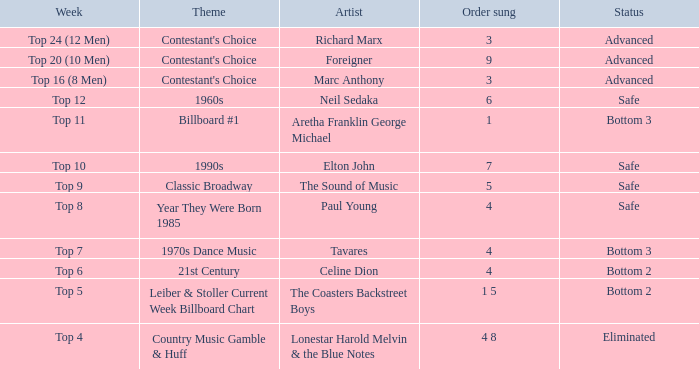What artist's song was performed in the week with theme of Billboard #1? Aretha Franklin George Michael. 